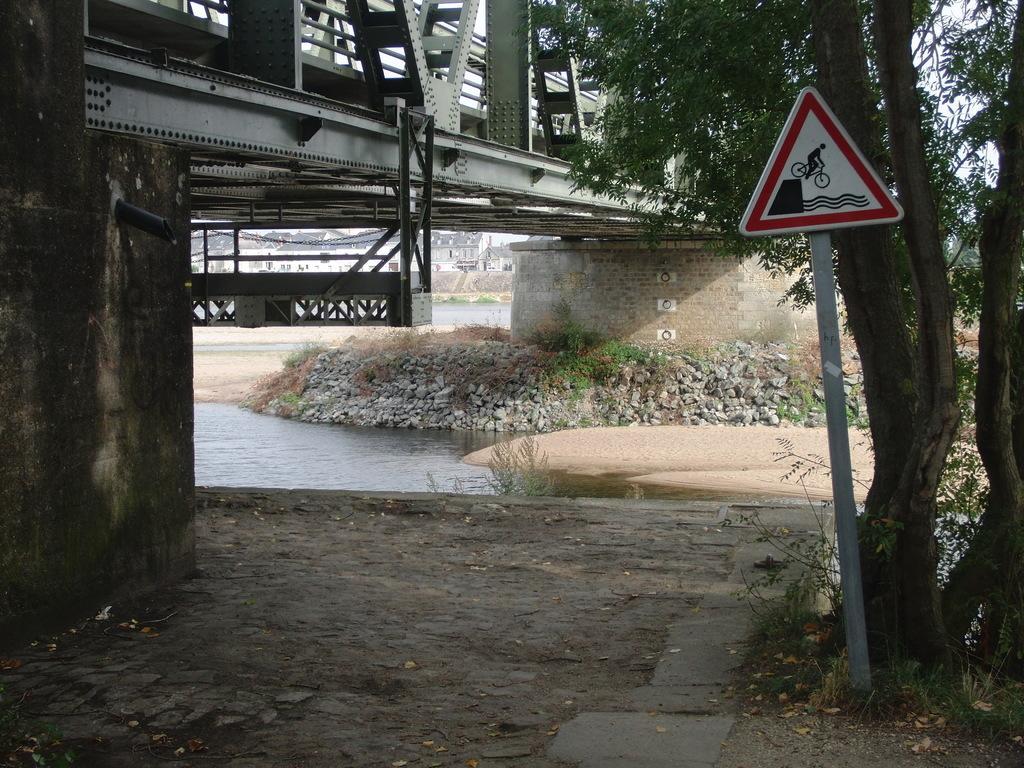Could you give a brief overview of what you see in this image? In this image I can see the sign board attached to the pole. In the background I can see the water, few trees in green color, the bridge and the sky is in white color. 